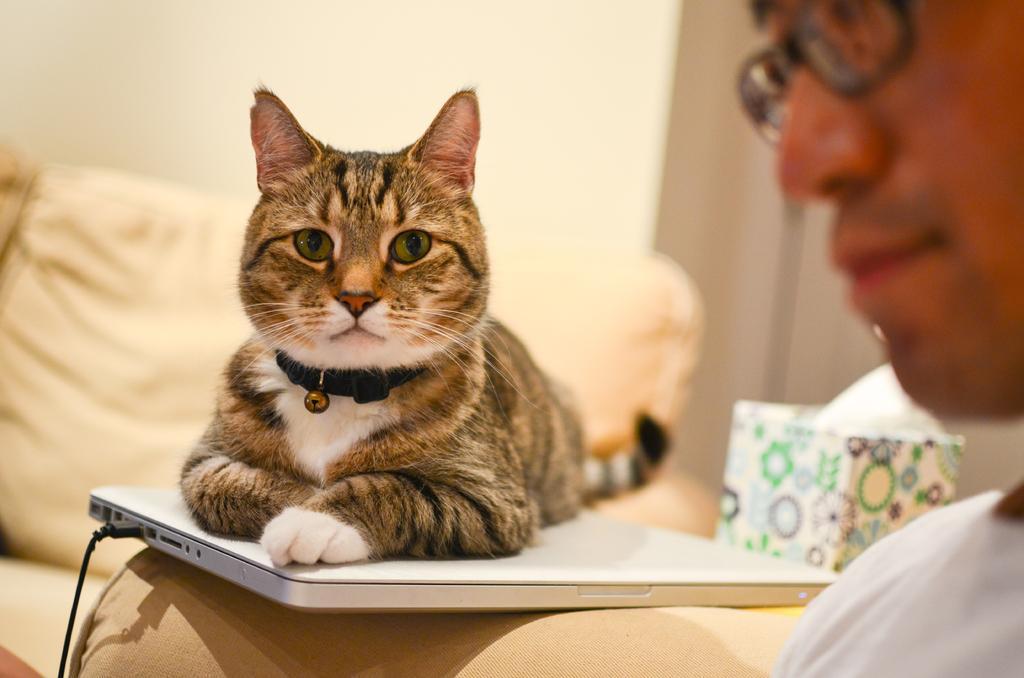Describe this image in one or two sentences. On the right side, we see a man in the white T-shirt is sitting on the sofa. Beside him, we see a sofa on which a laptop is placed. In the middle, we see a cat is sitting on the laptop. Beside that, we see a lamp and a box in white color. In the background, we see the pillows and a wall in white color. This picture is blurred in the background. 